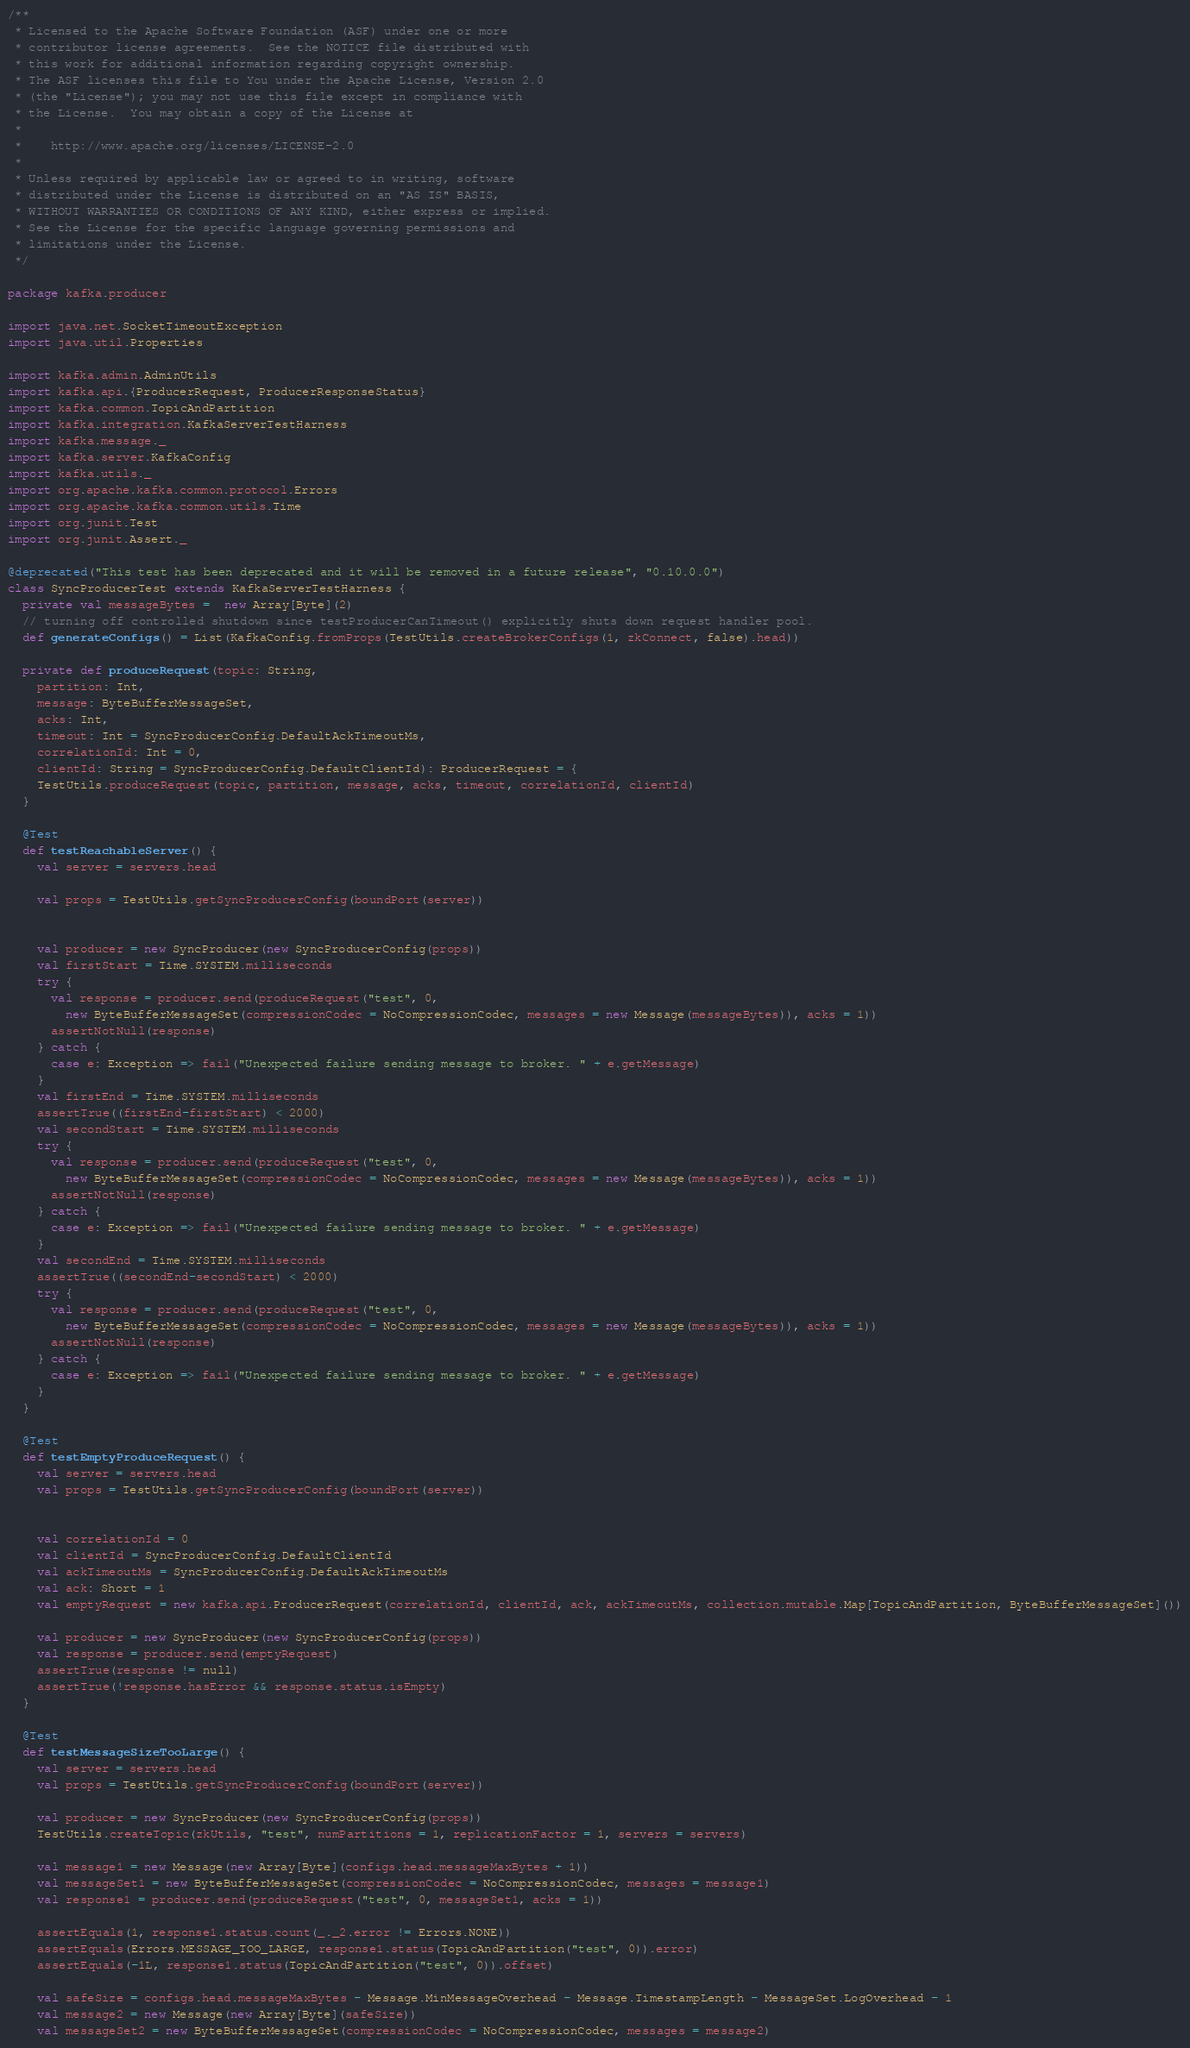<code> <loc_0><loc_0><loc_500><loc_500><_Scala_>/**
 * Licensed to the Apache Software Foundation (ASF) under one or more
 * contributor license agreements.  See the NOTICE file distributed with
 * this work for additional information regarding copyright ownership.
 * The ASF licenses this file to You under the Apache License, Version 2.0
 * (the "License"); you may not use this file except in compliance with
 * the License.  You may obtain a copy of the License at
 *
 *    http://www.apache.org/licenses/LICENSE-2.0
 *
 * Unless required by applicable law or agreed to in writing, software
 * distributed under the License is distributed on an "AS IS" BASIS,
 * WITHOUT WARRANTIES OR CONDITIONS OF ANY KIND, either express or implied.
 * See the License for the specific language governing permissions and
 * limitations under the License.
 */

package kafka.producer

import java.net.SocketTimeoutException
import java.util.Properties

import kafka.admin.AdminUtils
import kafka.api.{ProducerRequest, ProducerResponseStatus}
import kafka.common.TopicAndPartition
import kafka.integration.KafkaServerTestHarness
import kafka.message._
import kafka.server.KafkaConfig
import kafka.utils._
import org.apache.kafka.common.protocol.Errors
import org.apache.kafka.common.utils.Time
import org.junit.Test
import org.junit.Assert._

@deprecated("This test has been deprecated and it will be removed in a future release", "0.10.0.0")
class SyncProducerTest extends KafkaServerTestHarness {
  private val messageBytes =  new Array[Byte](2)
  // turning off controlled shutdown since testProducerCanTimeout() explicitly shuts down request handler pool.
  def generateConfigs() = List(KafkaConfig.fromProps(TestUtils.createBrokerConfigs(1, zkConnect, false).head))

  private def produceRequest(topic: String,
    partition: Int,
    message: ByteBufferMessageSet,
    acks: Int,
    timeout: Int = SyncProducerConfig.DefaultAckTimeoutMs,
    correlationId: Int = 0,
    clientId: String = SyncProducerConfig.DefaultClientId): ProducerRequest = {
    TestUtils.produceRequest(topic, partition, message, acks, timeout, correlationId, clientId)
  }

  @Test
  def testReachableServer() {
    val server = servers.head

    val props = TestUtils.getSyncProducerConfig(boundPort(server))


    val producer = new SyncProducer(new SyncProducerConfig(props))
    val firstStart = Time.SYSTEM.milliseconds
    try {
      val response = producer.send(produceRequest("test", 0,
        new ByteBufferMessageSet(compressionCodec = NoCompressionCodec, messages = new Message(messageBytes)), acks = 1))
      assertNotNull(response)
    } catch {
      case e: Exception => fail("Unexpected failure sending message to broker. " + e.getMessage)
    }
    val firstEnd = Time.SYSTEM.milliseconds
    assertTrue((firstEnd-firstStart) < 2000)
    val secondStart = Time.SYSTEM.milliseconds
    try {
      val response = producer.send(produceRequest("test", 0,
        new ByteBufferMessageSet(compressionCodec = NoCompressionCodec, messages = new Message(messageBytes)), acks = 1))
      assertNotNull(response)
    } catch {
      case e: Exception => fail("Unexpected failure sending message to broker. " + e.getMessage)
    }
    val secondEnd = Time.SYSTEM.milliseconds
    assertTrue((secondEnd-secondStart) < 2000)
    try {
      val response = producer.send(produceRequest("test", 0,
        new ByteBufferMessageSet(compressionCodec = NoCompressionCodec, messages = new Message(messageBytes)), acks = 1))
      assertNotNull(response)
    } catch {
      case e: Exception => fail("Unexpected failure sending message to broker. " + e.getMessage)
    }
  }

  @Test
  def testEmptyProduceRequest() {
    val server = servers.head
    val props = TestUtils.getSyncProducerConfig(boundPort(server))


    val correlationId = 0
    val clientId = SyncProducerConfig.DefaultClientId
    val ackTimeoutMs = SyncProducerConfig.DefaultAckTimeoutMs
    val ack: Short = 1
    val emptyRequest = new kafka.api.ProducerRequest(correlationId, clientId, ack, ackTimeoutMs, collection.mutable.Map[TopicAndPartition, ByteBufferMessageSet]())

    val producer = new SyncProducer(new SyncProducerConfig(props))
    val response = producer.send(emptyRequest)
    assertTrue(response != null)
    assertTrue(!response.hasError && response.status.isEmpty)
  }

  @Test
  def testMessageSizeTooLarge() {
    val server = servers.head
    val props = TestUtils.getSyncProducerConfig(boundPort(server))

    val producer = new SyncProducer(new SyncProducerConfig(props))
    TestUtils.createTopic(zkUtils, "test", numPartitions = 1, replicationFactor = 1, servers = servers)

    val message1 = new Message(new Array[Byte](configs.head.messageMaxBytes + 1))
    val messageSet1 = new ByteBufferMessageSet(compressionCodec = NoCompressionCodec, messages = message1)
    val response1 = producer.send(produceRequest("test", 0, messageSet1, acks = 1))

    assertEquals(1, response1.status.count(_._2.error != Errors.NONE))
    assertEquals(Errors.MESSAGE_TOO_LARGE, response1.status(TopicAndPartition("test", 0)).error)
    assertEquals(-1L, response1.status(TopicAndPartition("test", 0)).offset)

    val safeSize = configs.head.messageMaxBytes - Message.MinMessageOverhead - Message.TimestampLength - MessageSet.LogOverhead - 1
    val message2 = new Message(new Array[Byte](safeSize))
    val messageSet2 = new ByteBufferMessageSet(compressionCodec = NoCompressionCodec, messages = message2)</code> 